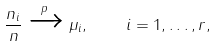<formula> <loc_0><loc_0><loc_500><loc_500>\frac { n _ { i } } { n } \xrightarrow { p } \mu _ { i } , \quad i = 1 , \dots , r ,</formula> 